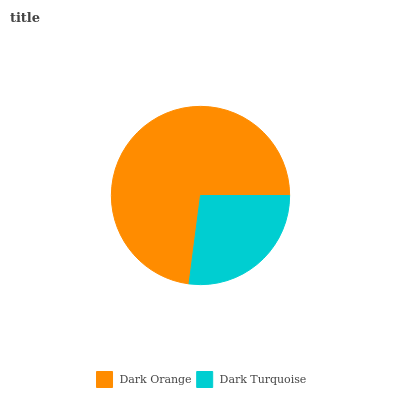Is Dark Turquoise the minimum?
Answer yes or no. Yes. Is Dark Orange the maximum?
Answer yes or no. Yes. Is Dark Turquoise the maximum?
Answer yes or no. No. Is Dark Orange greater than Dark Turquoise?
Answer yes or no. Yes. Is Dark Turquoise less than Dark Orange?
Answer yes or no. Yes. Is Dark Turquoise greater than Dark Orange?
Answer yes or no. No. Is Dark Orange less than Dark Turquoise?
Answer yes or no. No. Is Dark Orange the high median?
Answer yes or no. Yes. Is Dark Turquoise the low median?
Answer yes or no. Yes. Is Dark Turquoise the high median?
Answer yes or no. No. Is Dark Orange the low median?
Answer yes or no. No. 